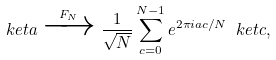<formula> <loc_0><loc_0><loc_500><loc_500>\ k e t { a } \xrightarrow { F _ { N } } \frac { 1 } { \sqrt { N } } \sum _ { c = 0 } ^ { N - 1 } e ^ { 2 \pi i a c / N } \ k e t { c } ,</formula> 